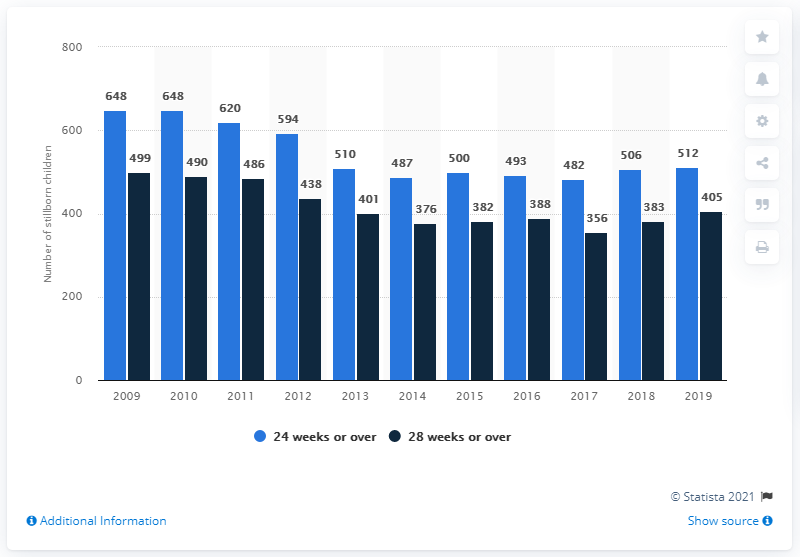Give some essential details in this illustration. In 2010, there was a significant gap between two sections. In 2015, there was a small but noticeable increase in the number of stillborn children. When was the 24 weeks or over section at its peak? It reached its peak in [2009, 2010]. 